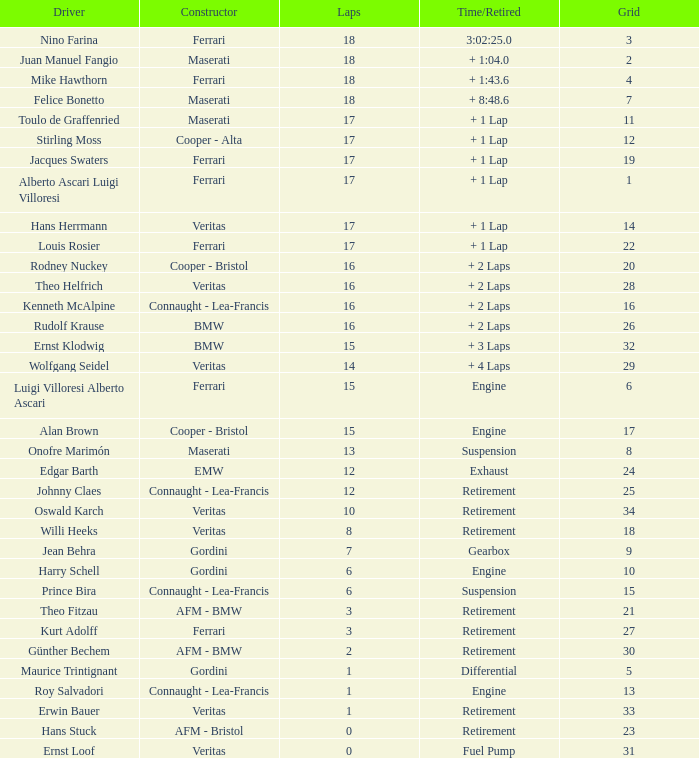Who has the low lap total in a maserati with grid 2? 18.0. 